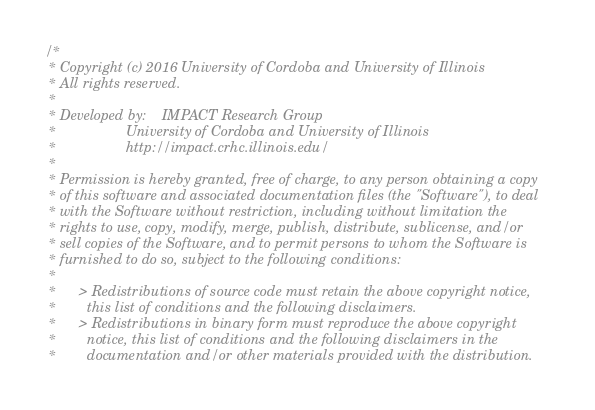Convert code to text. <code><loc_0><loc_0><loc_500><loc_500><_Cuda_>/*
 * Copyright (c) 2016 University of Cordoba and University of Illinois
 * All rights reserved.
 *
 * Developed by:    IMPACT Research Group
 *                  University of Cordoba and University of Illinois
 *                  http://impact.crhc.illinois.edu/
 *
 * Permission is hereby granted, free of charge, to any person obtaining a copy
 * of this software and associated documentation files (the "Software"), to deal
 * with the Software without restriction, including without limitation the 
 * rights to use, copy, modify, merge, publish, distribute, sublicense, and/or
 * sell copies of the Software, and to permit persons to whom the Software is
 * furnished to do so, subject to the following conditions:
 *
 *      > Redistributions of source code must retain the above copyright notice,
 *        this list of conditions and the following disclaimers.
 *      > Redistributions in binary form must reproduce the above copyright
 *        notice, this list of conditions and the following disclaimers in the
 *        documentation and/or other materials provided with the distribution.</code> 